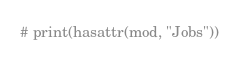Convert code to text. <code><loc_0><loc_0><loc_500><loc_500><_Python_># print(hasattr(mod, "Jobs"))
</code> 